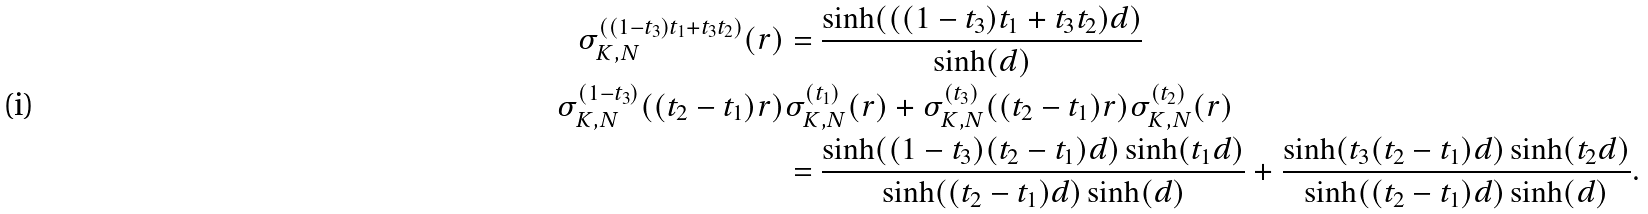<formula> <loc_0><loc_0><loc_500><loc_500>\sigma _ { K , N } ^ { ( ( 1 - t _ { 3 } ) t _ { 1 } + t _ { 3 } t _ { 2 } ) } ( r ) & = \frac { \sinh ( ( ( 1 - t _ { 3 } ) t _ { 1 } + t _ { 3 } t _ { 2 } ) d ) } { \sinh ( d ) } \\ \sigma _ { K , N } ^ { ( 1 - t _ { 3 } ) } ( ( t _ { 2 } - t _ { 1 } ) r ) & \sigma _ { K , N } ^ { ( t _ { 1 } ) } ( r ) + \sigma _ { K , N } ^ { ( t _ { 3 } ) } ( ( t _ { 2 } - t _ { 1 } ) r ) \sigma _ { K , N } ^ { ( t _ { 2 } ) } ( r ) \\ & = \frac { \sinh ( ( 1 - t _ { 3 } ) ( t _ { 2 } - t _ { 1 } ) d ) \sinh ( t _ { 1 } d ) } { \sinh ( ( t _ { 2 } - t _ { 1 } ) d ) \sinh ( d ) } + \frac { \sinh ( t _ { 3 } ( t _ { 2 } - t _ { 1 } ) d ) \sinh ( t _ { 2 } d ) } { \sinh ( ( t _ { 2 } - t _ { 1 } ) d ) \sinh ( d ) } . \\</formula> 